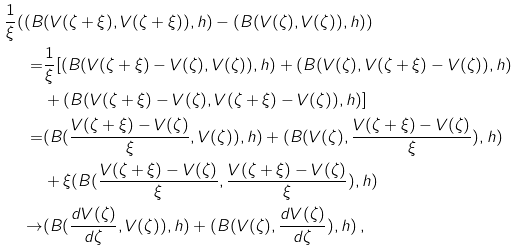<formula> <loc_0><loc_0><loc_500><loc_500>\frac { 1 } { \xi } ( ( B & ( V ( \zeta + \xi ) , V ( \zeta + \xi ) ) , h ) - ( B ( V ( \zeta ) , V ( \zeta ) ) , h ) ) \\ = & \frac { 1 } { \xi } [ ( B ( V ( \zeta + \xi ) - V ( \zeta ) , V ( \zeta ) ) , h ) + ( B ( V ( \zeta ) , V ( \zeta + \xi ) - V ( \zeta ) ) , h ) \\ & + ( B ( V ( \zeta + \xi ) - V ( \zeta ) , V ( \zeta + \xi ) - V ( \zeta ) ) , h ) ] \\ = & ( B ( \frac { V ( \zeta + \xi ) - V ( \zeta ) } { \xi } , V ( \zeta ) ) , h ) + ( B ( V ( \zeta ) , \frac { V ( \zeta + \xi ) - V ( \zeta ) } { \xi } ) , h ) \\ & + \xi ( B ( \frac { V ( \zeta + \xi ) - V ( \zeta ) } { \xi } , \frac { V ( \zeta + \xi ) - V ( \zeta ) } { \xi } ) , h ) \\ \to & ( B ( \frac { d V ( \zeta ) } { d \zeta } , V ( \zeta ) ) , h ) + ( B ( V ( \zeta ) , \frac { d V ( \zeta ) } { d \zeta } ) , h ) \, ,</formula> 